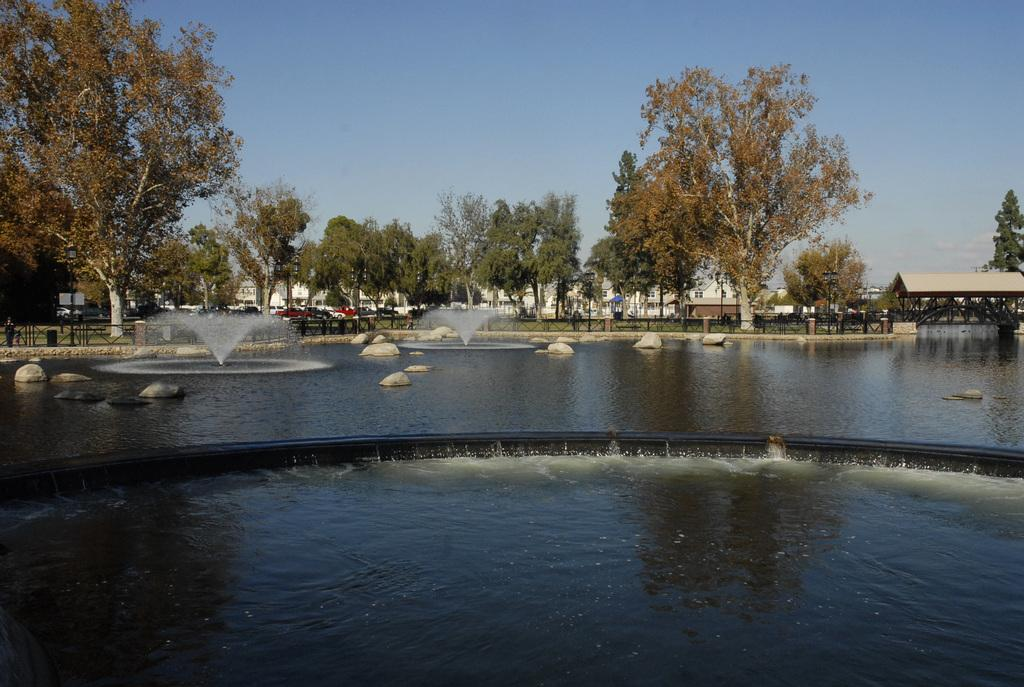What body of water is present in the image? There is a pond in the image. What features can be seen within the pond? There are fountains and stones in the pond. What can be seen in the background of the image? There are trees and a shed in the background of the image. What is visible in the sky in the image? The sky is visible in the background of the image. What type of creature is sitting on the robin's nest in the image? There is no robin or nest present in the image; it features a pond with fountains and stones. 